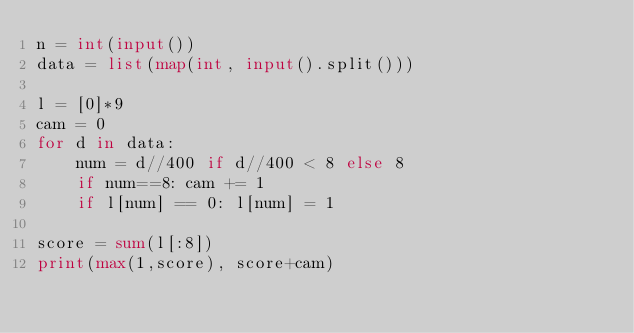Convert code to text. <code><loc_0><loc_0><loc_500><loc_500><_Python_>n = int(input())
data = list(map(int, input().split()))

l = [0]*9
cam = 0
for d in data:
    num = d//400 if d//400 < 8 else 8
    if num==8: cam += 1
    if l[num] == 0: l[num] = 1

score = sum(l[:8])
print(max(1,score), score+cam)

</code> 